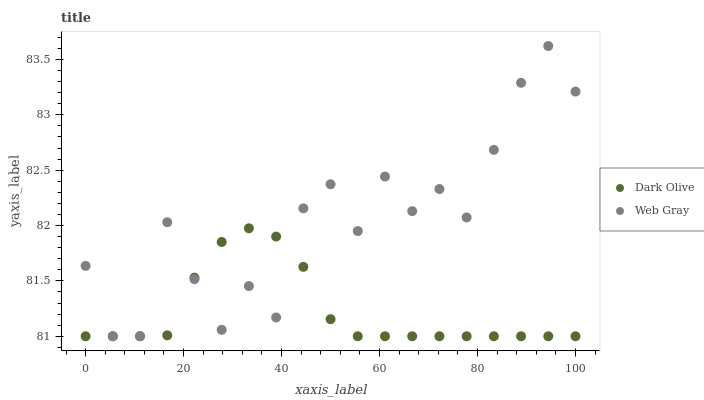Does Dark Olive have the minimum area under the curve?
Answer yes or no. Yes. Does Web Gray have the maximum area under the curve?
Answer yes or no. Yes. Does Web Gray have the minimum area under the curve?
Answer yes or no. No. Is Dark Olive the smoothest?
Answer yes or no. Yes. Is Web Gray the roughest?
Answer yes or no. Yes. Is Web Gray the smoothest?
Answer yes or no. No. Does Dark Olive have the lowest value?
Answer yes or no. Yes. Does Web Gray have the highest value?
Answer yes or no. Yes. Does Dark Olive intersect Web Gray?
Answer yes or no. Yes. Is Dark Olive less than Web Gray?
Answer yes or no. No. Is Dark Olive greater than Web Gray?
Answer yes or no. No. 